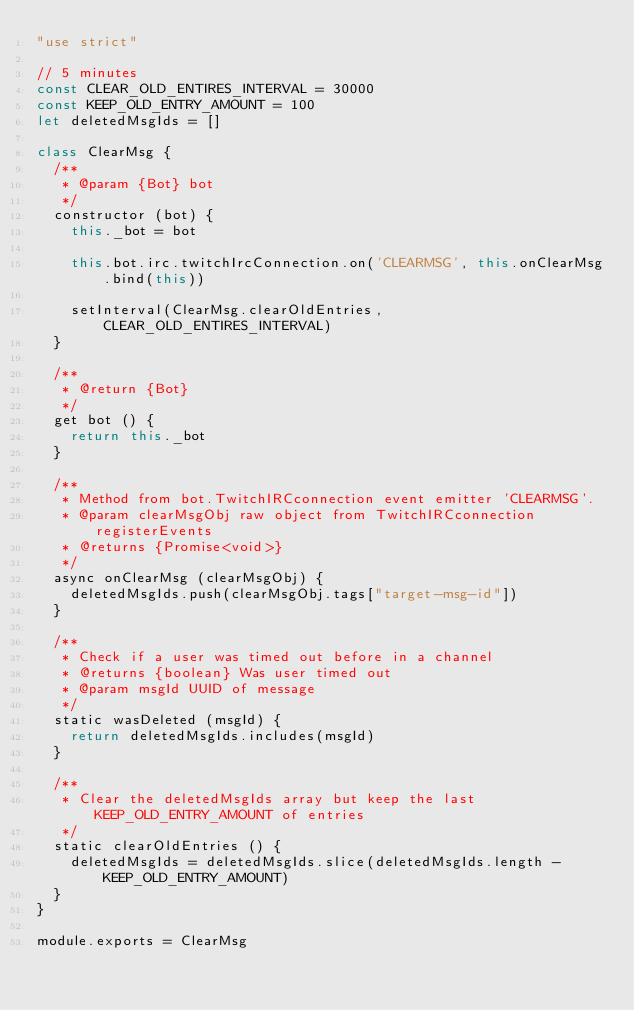<code> <loc_0><loc_0><loc_500><loc_500><_JavaScript_>"use strict"

// 5 minutes
const CLEAR_OLD_ENTIRES_INTERVAL = 30000
const KEEP_OLD_ENTRY_AMOUNT = 100
let deletedMsgIds = []

class ClearMsg {
  /**
   * @param {Bot} bot
   */
  constructor (bot) {
    this._bot = bot

    this.bot.irc.twitchIrcConnection.on('CLEARMSG', this.onClearMsg.bind(this))

    setInterval(ClearMsg.clearOldEntries, CLEAR_OLD_ENTIRES_INTERVAL)
  }

  /**
   * @return {Bot}
   */
  get bot () {
    return this._bot
  }

  /**
   * Method from bot.TwitchIRCconnection event emitter 'CLEARMSG'.
   * @param clearMsgObj raw object from TwitchIRCconnection registerEvents
   * @returns {Promise<void>}
   */
  async onClearMsg (clearMsgObj) {
    deletedMsgIds.push(clearMsgObj.tags["target-msg-id"])
  }

  /**
   * Check if a user was timed out before in a channel
   * @returns {boolean} Was user timed out
   * @param msgId UUID of message
   */
  static wasDeleted (msgId) {
    return deletedMsgIds.includes(msgId)
  }

  /**
   * Clear the deletedMsgIds array but keep the last KEEP_OLD_ENTRY_AMOUNT of entries
   */
  static clearOldEntries () {
    deletedMsgIds = deletedMsgIds.slice(deletedMsgIds.length - KEEP_OLD_ENTRY_AMOUNT)
  }
}

module.exports = ClearMsg
</code> 